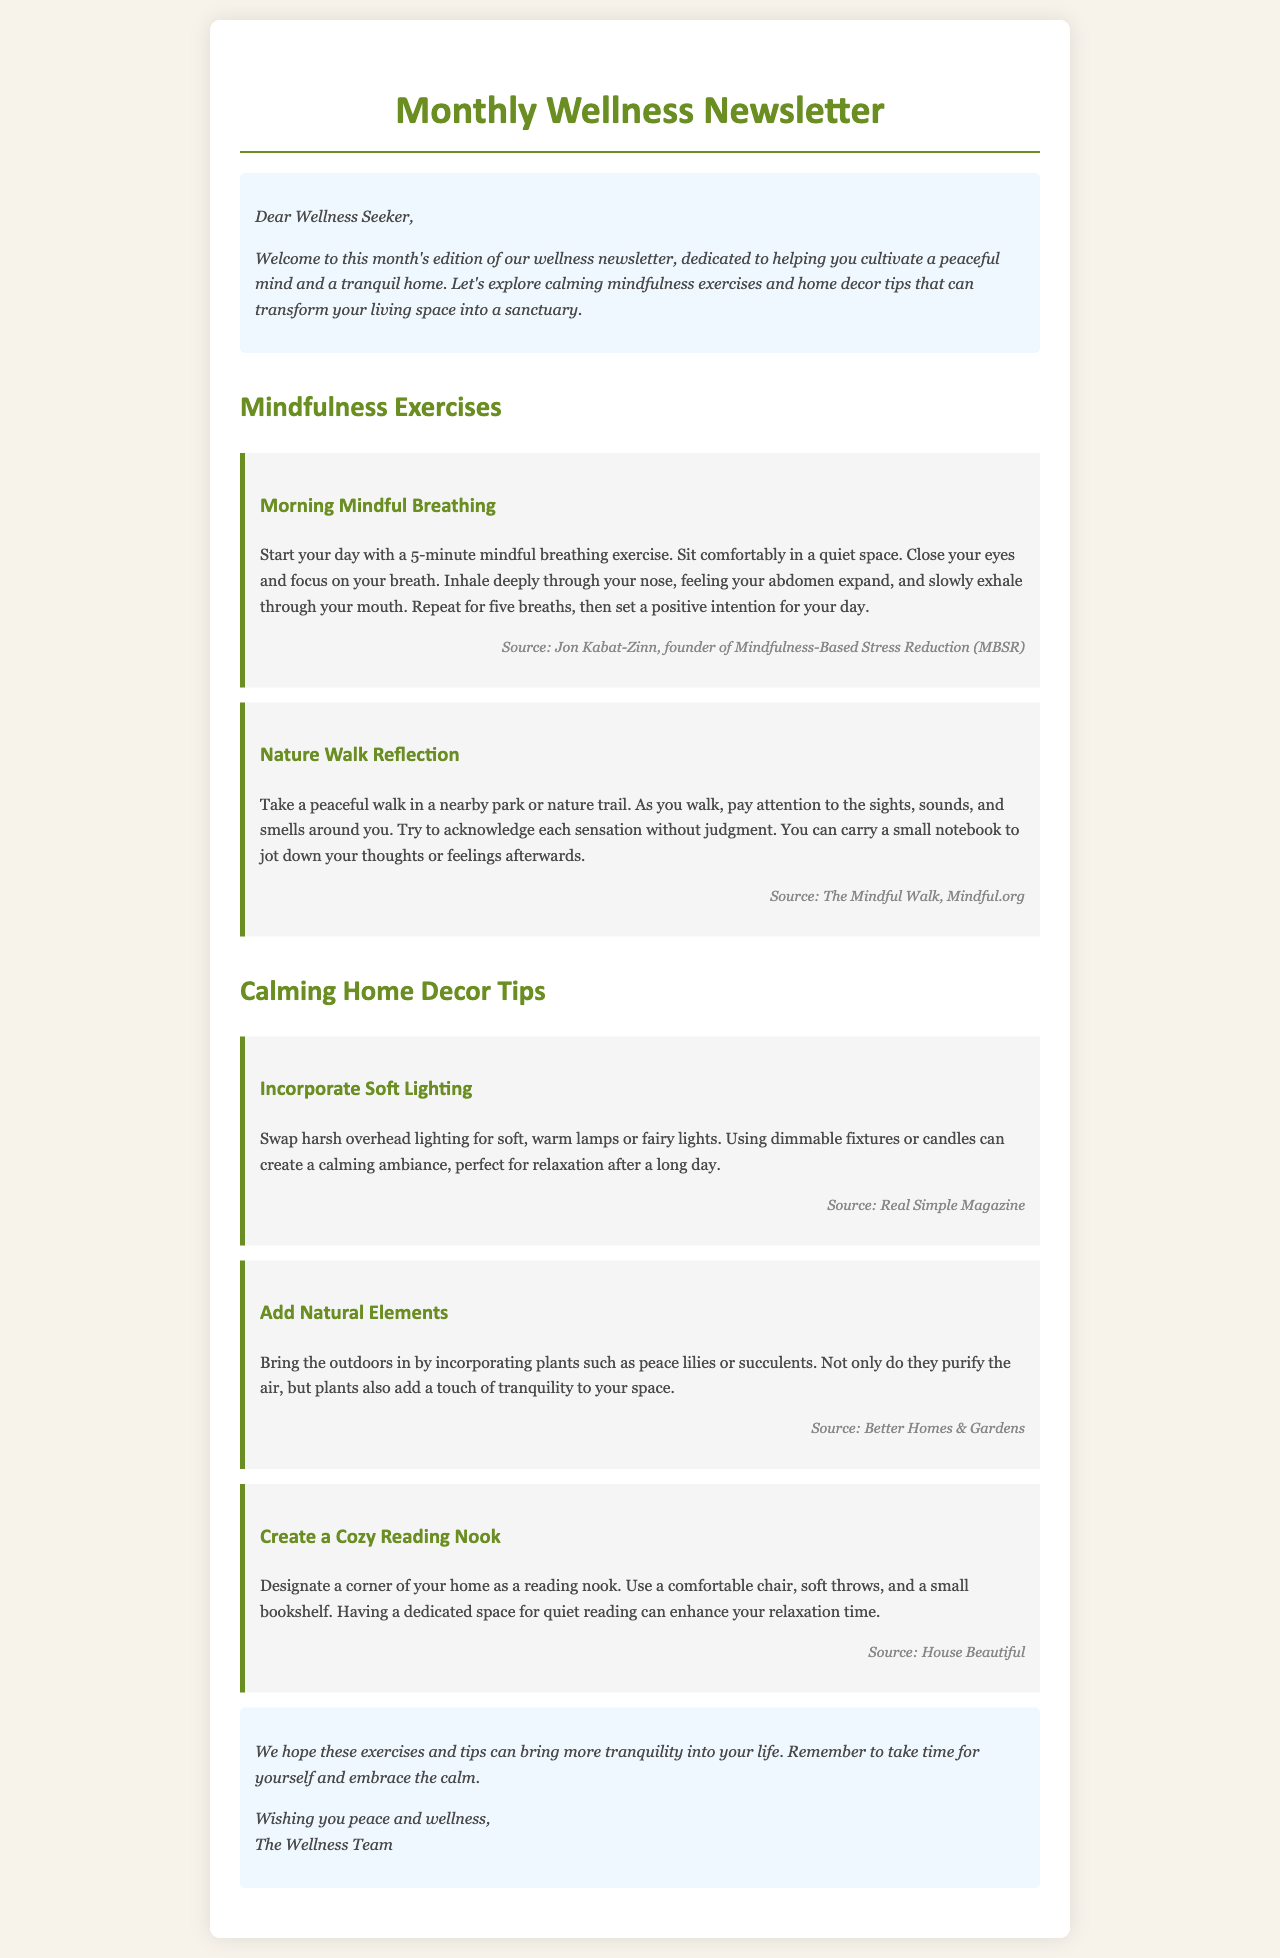What is the title of the newsletter? The title is prominently displayed at the top of the document.
Answer: Monthly Wellness Newsletter Who is the newsletter addressing? The salutation at the beginning indicates the audience of the newsletter.
Answer: Wellness Seeker What is the first mindfulness exercise mentioned? It is listed under the "Mindfulness Exercises" section with a specific heading.
Answer: Morning Mindful Breathing What should you do during the Nature Walk Reflection? The instructions specify actions to be taken during this activity.
Answer: Acknowledge each sensation without judgment What type of lighting is recommended for calming home decor? This recommendation is found in the "Calming Home Decor Tips" section.
Answer: Soft lighting Which plant is suggested to incorporate for tranquility? The document lists specific plants for enhancing tranquility in the home.
Answer: Peace lilies How can you create a cozy reading nook? The document outlines suggestions for designing a comfortable reading space.
Answer: Use a comfortable chair What emotion does the newsletter aim to encourage? The closing statement reflects the overall goal of the newsletter.
Answer: Tranquility What is the closing wish from the Wellness Team? The last paragraph contains the farewell message from the team.
Answer: Peace and wellness 